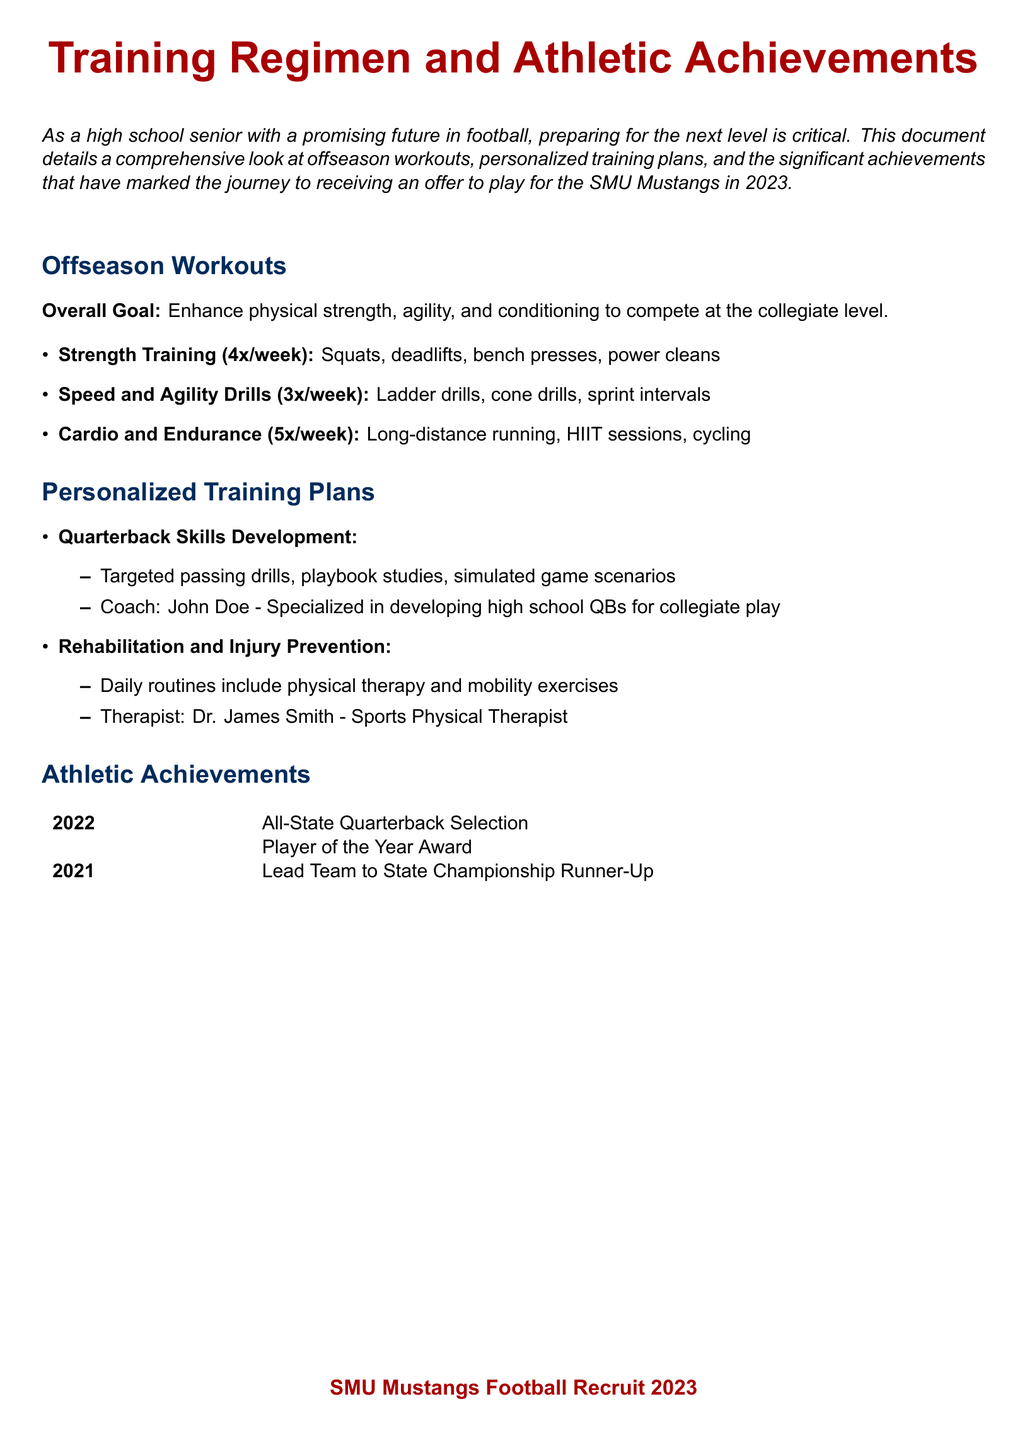What is the overall goal of the offseason workouts? The overall goal is stated in the document as enhancing physical strength, agility, and conditioning to compete at the collegiate level.
Answer: Enhance physical strength, agility, and conditioning How many times a week is strength training conducted? The document lists the frequency of strength training sessions, which is four times a week.
Answer: 4x/week Who is the coach specializing in developing high school quarterbacks? The document mentions a coach specialized in quarterback development, providing a name.
Answer: John Doe What year was the Player of the Year Award received? The document lists the achievements by year, indicating when the Player of the Year Award was won.
Answer: 2022 What type of drills are included in the speed and agility training? The document specifies the types of drills that are part of the speed and agility training regimen.
Answer: Ladder drills, cone drills, sprint intervals How many times a week is cardio and endurance training performed? According to the document, cardio and endurance training sessions take place five times a week.
Answer: 5x/week What rehabilitation routine is included in the personalized training plans? The document highlights a specific aspect of personalized training focused on rehabilitation.
Answer: Physical therapy and mobility exercises In what year did the athlete lead their team to the state championship runner-up? The document provides a specific year when this achievement occurred.
Answer: 2021 